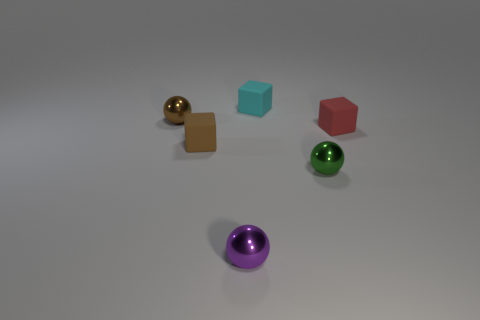What color is the small rubber object in front of the matte cube that is right of the cyan cube?
Make the answer very short. Brown. What is the shape of the tiny cyan rubber object?
Your answer should be compact. Cube. There is a thing that is behind the red thing and to the left of the purple metal ball; what is its shape?
Offer a terse response. Sphere. There is a matte thing on the right side of the small rubber thing that is behind the shiny thing that is behind the red matte block; what is its shape?
Offer a terse response. Cube. There is a brown object that is the same material as the purple object; what is its shape?
Your response must be concise. Sphere. Is the number of tiny objects that are in front of the tiny brown matte block less than the number of small objects?
Offer a terse response. Yes. What is the color of the small rubber object on the left side of the tiny cyan matte cube?
Keep it short and to the point. Brown. Are there any red shiny things that have the same shape as the small purple metal object?
Provide a succinct answer. No. What number of brown matte things have the same shape as the small red object?
Offer a terse response. 1. Is the number of purple blocks less than the number of small purple metallic objects?
Ensure brevity in your answer.  Yes. 